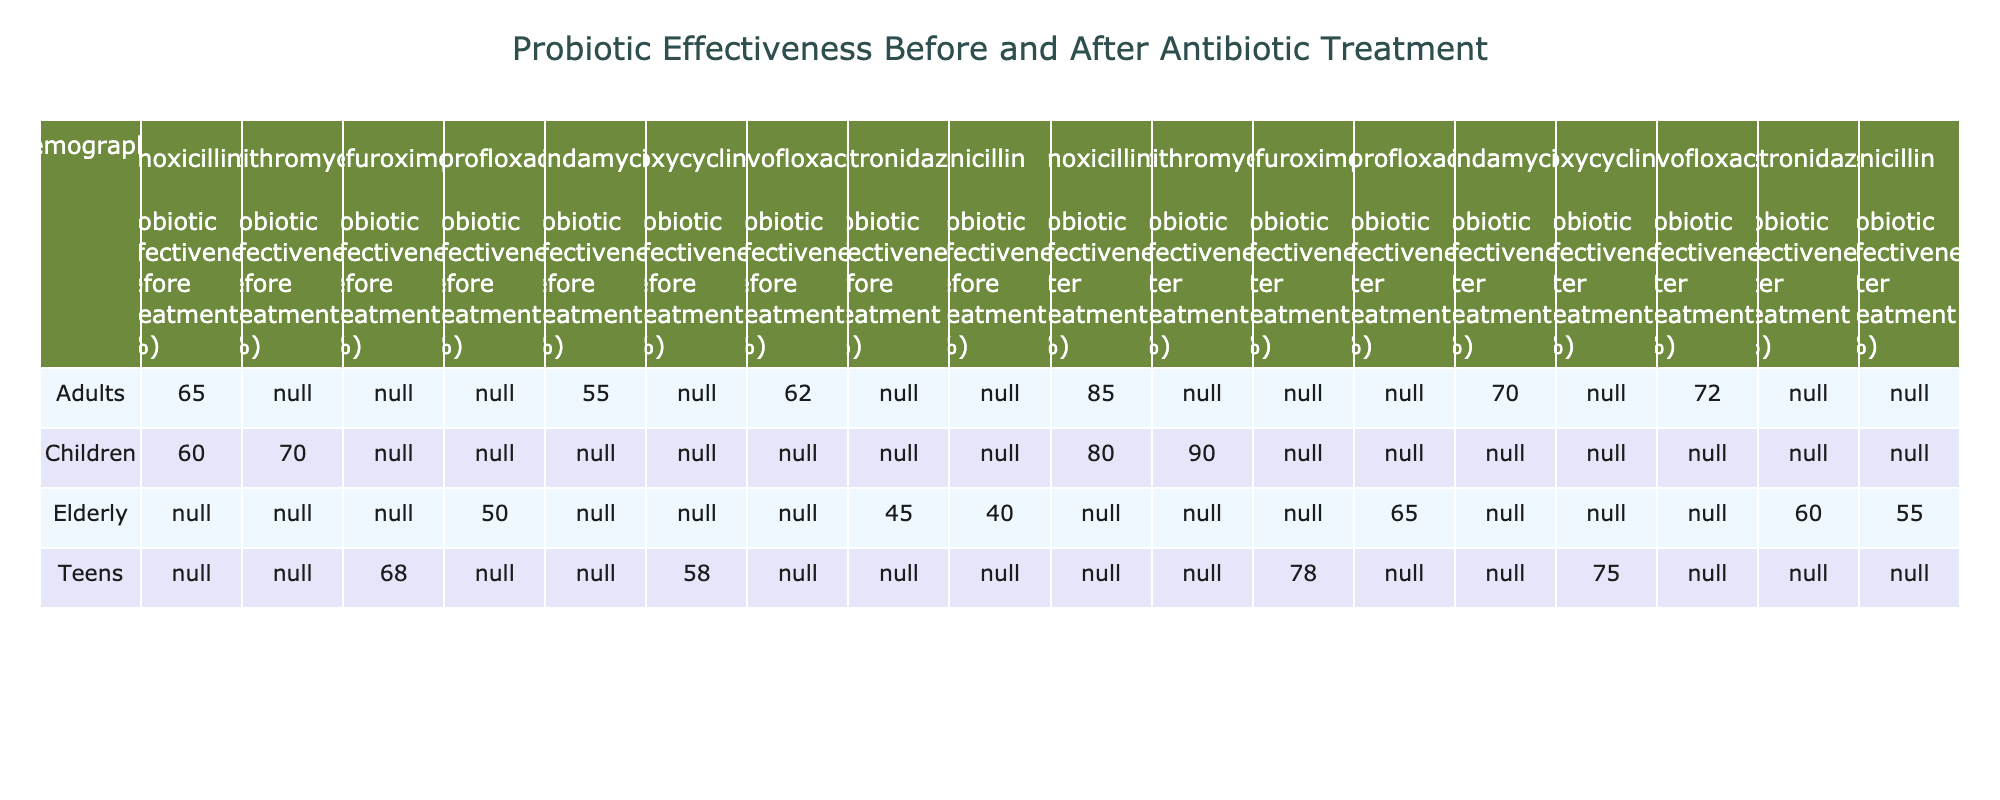What is the probiotic effectiveness percentage for children before antibiotic treatment? Referring to the table, the effectiveness for children before treatment is listed under the "Children" row and "Probiotic Effectiveness Before Treatment (%)" column, which is 60%.
Answer: 60% Which demographic showed the least improvement in probiotic effectiveness after antibiotic treatment? To determine this, I will look at the "Probiotic Effectiveness After Treatment (%)" for each demographic. The values are Children 90, Adults 85, Teens 75, Elderly 65. The Elderly show the least improvement with a post-treatment effectiveness of 65%.
Answer: Elderly What is the average probiotic effectiveness before antibiotic treatment for all demographics combined? I will total the percentages for effectiveness before treatment: 60 + 55 + 50 + 58 + 65 + 45 + 70 + 68 + 62 + 40 =  660. There are 10 demographics, so the average is 660 / 10 = 66.
Answer: 66 Do adults using Amoxicillin have higher probiotic effectiveness after treatment compared to children using Azithromycin? Looking at the effectiveness after treatment for Adults using Amoxicillin is 85% and for Children using Azithromycin it is 90%. Since 85% is less than 90%, the answer is no.
Answer: No Which antibiotic had the highest post-treatment probiotic effectiveness among the tested demographics? I will identify the highest values from the "Probiotic Effectiveness After Treatment (%)" column: Children with Azithromycin at 90%, Adults with Amoxicillin at 85%, Teens with Doxycycline at 75%, Etc. The highest effectiveness after treatment is 90% for Children using Azithromycin.
Answer: Azithromycin What is the difference in probiotic effectiveness before and after antibiotic treatment for teens? The effectiveness for teens before treatment is 58% and after is 75%. The difference is calculated as 75 - 58 = 17.
Answer: 17 Is the probiotic effectiveness after antibiotic treatment better for adults compared to the elderly? The effectiveness after treatment is 85% for adults and 65% for the elderly. Since 85% is greater than 65%, the answer is yes.
Answer: Yes Which antibiotic showed the lowest probiotic effectiveness before treatment? The lowest effectiveness in the "Probiotic Effectiveness Before Treatment (%)" column is 40% for Elderly using Penicillin.
Answer: Penicillin 